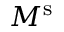Convert formula to latex. <formula><loc_0><loc_0><loc_500><loc_500>M ^ { s }</formula> 